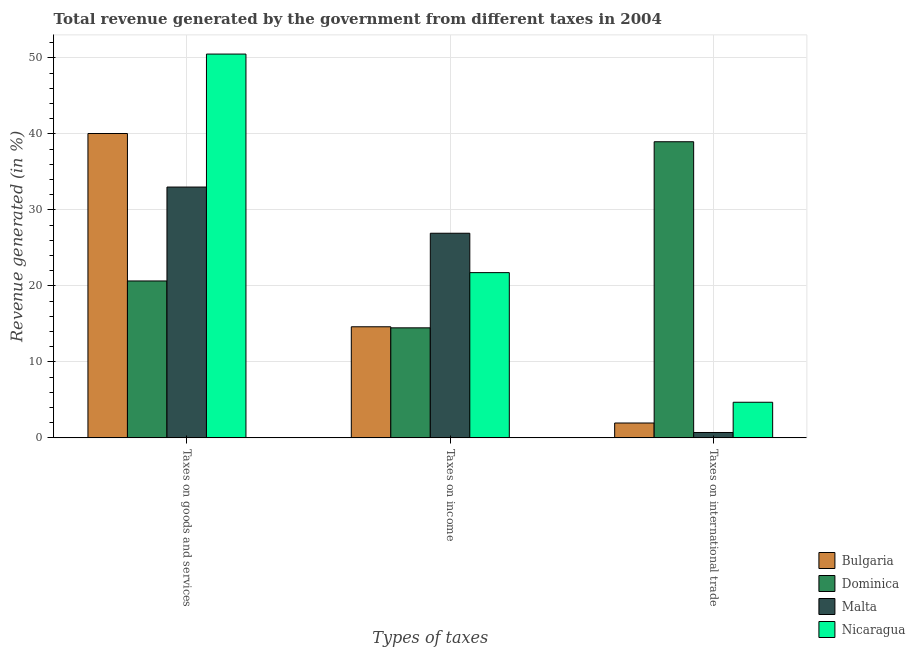Are the number of bars on each tick of the X-axis equal?
Ensure brevity in your answer.  Yes. How many bars are there on the 1st tick from the left?
Your answer should be compact. 4. How many bars are there on the 2nd tick from the right?
Your response must be concise. 4. What is the label of the 2nd group of bars from the left?
Offer a terse response. Taxes on income. What is the percentage of revenue generated by taxes on income in Bulgaria?
Make the answer very short. 14.62. Across all countries, what is the maximum percentage of revenue generated by taxes on goods and services?
Offer a terse response. 50.51. Across all countries, what is the minimum percentage of revenue generated by taxes on income?
Offer a terse response. 14.48. In which country was the percentage of revenue generated by taxes on goods and services maximum?
Your answer should be very brief. Nicaragua. In which country was the percentage of revenue generated by taxes on income minimum?
Your response must be concise. Dominica. What is the total percentage of revenue generated by taxes on goods and services in the graph?
Make the answer very short. 144.23. What is the difference between the percentage of revenue generated by taxes on goods and services in Nicaragua and that in Bulgaria?
Your response must be concise. 10.46. What is the difference between the percentage of revenue generated by taxes on goods and services in Bulgaria and the percentage of revenue generated by tax on international trade in Malta?
Provide a succinct answer. 39.35. What is the average percentage of revenue generated by taxes on goods and services per country?
Give a very brief answer. 36.06. What is the difference between the percentage of revenue generated by taxes on goods and services and percentage of revenue generated by tax on international trade in Bulgaria?
Your response must be concise. 38.1. What is the ratio of the percentage of revenue generated by taxes on income in Nicaragua to that in Dominica?
Give a very brief answer. 1.5. Is the percentage of revenue generated by tax on international trade in Dominica less than that in Malta?
Your response must be concise. No. Is the difference between the percentage of revenue generated by tax on international trade in Bulgaria and Malta greater than the difference between the percentage of revenue generated by taxes on goods and services in Bulgaria and Malta?
Ensure brevity in your answer.  No. What is the difference between the highest and the second highest percentage of revenue generated by tax on international trade?
Your response must be concise. 34.29. What is the difference between the highest and the lowest percentage of revenue generated by tax on international trade?
Your response must be concise. 38.26. Is the sum of the percentage of revenue generated by taxes on income in Nicaragua and Malta greater than the maximum percentage of revenue generated by taxes on goods and services across all countries?
Make the answer very short. No. What does the 3rd bar from the left in Taxes on income represents?
Ensure brevity in your answer.  Malta. What does the 3rd bar from the right in Taxes on goods and services represents?
Your answer should be compact. Dominica. How many bars are there?
Your answer should be compact. 12. Are all the bars in the graph horizontal?
Provide a short and direct response. No. Are the values on the major ticks of Y-axis written in scientific E-notation?
Give a very brief answer. No. Where does the legend appear in the graph?
Offer a terse response. Bottom right. How many legend labels are there?
Ensure brevity in your answer.  4. What is the title of the graph?
Provide a short and direct response. Total revenue generated by the government from different taxes in 2004. Does "Other small states" appear as one of the legend labels in the graph?
Make the answer very short. No. What is the label or title of the X-axis?
Ensure brevity in your answer.  Types of taxes. What is the label or title of the Y-axis?
Keep it short and to the point. Revenue generated (in %). What is the Revenue generated (in %) of Bulgaria in Taxes on goods and services?
Offer a terse response. 40.06. What is the Revenue generated (in %) of Dominica in Taxes on goods and services?
Your answer should be very brief. 20.65. What is the Revenue generated (in %) in Malta in Taxes on goods and services?
Provide a short and direct response. 33.01. What is the Revenue generated (in %) of Nicaragua in Taxes on goods and services?
Give a very brief answer. 50.51. What is the Revenue generated (in %) in Bulgaria in Taxes on income?
Keep it short and to the point. 14.62. What is the Revenue generated (in %) in Dominica in Taxes on income?
Provide a short and direct response. 14.48. What is the Revenue generated (in %) in Malta in Taxes on income?
Keep it short and to the point. 26.93. What is the Revenue generated (in %) of Nicaragua in Taxes on income?
Make the answer very short. 21.75. What is the Revenue generated (in %) of Bulgaria in Taxes on international trade?
Provide a succinct answer. 1.96. What is the Revenue generated (in %) in Dominica in Taxes on international trade?
Provide a succinct answer. 38.97. What is the Revenue generated (in %) of Malta in Taxes on international trade?
Provide a succinct answer. 0.71. What is the Revenue generated (in %) of Nicaragua in Taxes on international trade?
Give a very brief answer. 4.69. Across all Types of taxes, what is the maximum Revenue generated (in %) in Bulgaria?
Make the answer very short. 40.06. Across all Types of taxes, what is the maximum Revenue generated (in %) of Dominica?
Ensure brevity in your answer.  38.97. Across all Types of taxes, what is the maximum Revenue generated (in %) of Malta?
Your answer should be compact. 33.01. Across all Types of taxes, what is the maximum Revenue generated (in %) in Nicaragua?
Make the answer very short. 50.51. Across all Types of taxes, what is the minimum Revenue generated (in %) of Bulgaria?
Your response must be concise. 1.96. Across all Types of taxes, what is the minimum Revenue generated (in %) of Dominica?
Your response must be concise. 14.48. Across all Types of taxes, what is the minimum Revenue generated (in %) of Malta?
Give a very brief answer. 0.71. Across all Types of taxes, what is the minimum Revenue generated (in %) of Nicaragua?
Provide a succinct answer. 4.69. What is the total Revenue generated (in %) in Bulgaria in the graph?
Offer a terse response. 56.63. What is the total Revenue generated (in %) in Dominica in the graph?
Offer a very short reply. 74.1. What is the total Revenue generated (in %) of Malta in the graph?
Keep it short and to the point. 60.65. What is the total Revenue generated (in %) of Nicaragua in the graph?
Keep it short and to the point. 76.94. What is the difference between the Revenue generated (in %) of Bulgaria in Taxes on goods and services and that in Taxes on income?
Your answer should be very brief. 25.43. What is the difference between the Revenue generated (in %) of Dominica in Taxes on goods and services and that in Taxes on income?
Your response must be concise. 6.17. What is the difference between the Revenue generated (in %) of Malta in Taxes on goods and services and that in Taxes on income?
Provide a short and direct response. 6.08. What is the difference between the Revenue generated (in %) in Nicaragua in Taxes on goods and services and that in Taxes on income?
Offer a very short reply. 28.76. What is the difference between the Revenue generated (in %) in Bulgaria in Taxes on goods and services and that in Taxes on international trade?
Your answer should be compact. 38.1. What is the difference between the Revenue generated (in %) in Dominica in Taxes on goods and services and that in Taxes on international trade?
Provide a short and direct response. -18.32. What is the difference between the Revenue generated (in %) of Malta in Taxes on goods and services and that in Taxes on international trade?
Ensure brevity in your answer.  32.3. What is the difference between the Revenue generated (in %) in Nicaragua in Taxes on goods and services and that in Taxes on international trade?
Your response must be concise. 45.82. What is the difference between the Revenue generated (in %) in Bulgaria in Taxes on income and that in Taxes on international trade?
Keep it short and to the point. 12.66. What is the difference between the Revenue generated (in %) of Dominica in Taxes on income and that in Taxes on international trade?
Provide a short and direct response. -24.49. What is the difference between the Revenue generated (in %) of Malta in Taxes on income and that in Taxes on international trade?
Provide a short and direct response. 26.22. What is the difference between the Revenue generated (in %) in Nicaragua in Taxes on income and that in Taxes on international trade?
Offer a very short reply. 17.06. What is the difference between the Revenue generated (in %) in Bulgaria in Taxes on goods and services and the Revenue generated (in %) in Dominica in Taxes on income?
Offer a terse response. 25.57. What is the difference between the Revenue generated (in %) of Bulgaria in Taxes on goods and services and the Revenue generated (in %) of Malta in Taxes on income?
Provide a short and direct response. 13.13. What is the difference between the Revenue generated (in %) in Bulgaria in Taxes on goods and services and the Revenue generated (in %) in Nicaragua in Taxes on income?
Offer a terse response. 18.31. What is the difference between the Revenue generated (in %) of Dominica in Taxes on goods and services and the Revenue generated (in %) of Malta in Taxes on income?
Offer a very short reply. -6.28. What is the difference between the Revenue generated (in %) of Dominica in Taxes on goods and services and the Revenue generated (in %) of Nicaragua in Taxes on income?
Provide a succinct answer. -1.1. What is the difference between the Revenue generated (in %) of Malta in Taxes on goods and services and the Revenue generated (in %) of Nicaragua in Taxes on income?
Give a very brief answer. 11.26. What is the difference between the Revenue generated (in %) in Bulgaria in Taxes on goods and services and the Revenue generated (in %) in Dominica in Taxes on international trade?
Ensure brevity in your answer.  1.08. What is the difference between the Revenue generated (in %) of Bulgaria in Taxes on goods and services and the Revenue generated (in %) of Malta in Taxes on international trade?
Give a very brief answer. 39.35. What is the difference between the Revenue generated (in %) of Bulgaria in Taxes on goods and services and the Revenue generated (in %) of Nicaragua in Taxes on international trade?
Make the answer very short. 35.37. What is the difference between the Revenue generated (in %) in Dominica in Taxes on goods and services and the Revenue generated (in %) in Malta in Taxes on international trade?
Offer a terse response. 19.94. What is the difference between the Revenue generated (in %) in Dominica in Taxes on goods and services and the Revenue generated (in %) in Nicaragua in Taxes on international trade?
Your response must be concise. 15.96. What is the difference between the Revenue generated (in %) in Malta in Taxes on goods and services and the Revenue generated (in %) in Nicaragua in Taxes on international trade?
Keep it short and to the point. 28.32. What is the difference between the Revenue generated (in %) of Bulgaria in Taxes on income and the Revenue generated (in %) of Dominica in Taxes on international trade?
Provide a succinct answer. -24.35. What is the difference between the Revenue generated (in %) of Bulgaria in Taxes on income and the Revenue generated (in %) of Malta in Taxes on international trade?
Your answer should be compact. 13.91. What is the difference between the Revenue generated (in %) of Bulgaria in Taxes on income and the Revenue generated (in %) of Nicaragua in Taxes on international trade?
Make the answer very short. 9.93. What is the difference between the Revenue generated (in %) in Dominica in Taxes on income and the Revenue generated (in %) in Malta in Taxes on international trade?
Offer a very short reply. 13.77. What is the difference between the Revenue generated (in %) in Dominica in Taxes on income and the Revenue generated (in %) in Nicaragua in Taxes on international trade?
Your answer should be very brief. 9.79. What is the difference between the Revenue generated (in %) in Malta in Taxes on income and the Revenue generated (in %) in Nicaragua in Taxes on international trade?
Your answer should be very brief. 22.24. What is the average Revenue generated (in %) of Bulgaria per Types of taxes?
Your response must be concise. 18.88. What is the average Revenue generated (in %) of Dominica per Types of taxes?
Provide a succinct answer. 24.7. What is the average Revenue generated (in %) of Malta per Types of taxes?
Give a very brief answer. 20.22. What is the average Revenue generated (in %) in Nicaragua per Types of taxes?
Your answer should be very brief. 25.65. What is the difference between the Revenue generated (in %) in Bulgaria and Revenue generated (in %) in Dominica in Taxes on goods and services?
Your response must be concise. 19.41. What is the difference between the Revenue generated (in %) of Bulgaria and Revenue generated (in %) of Malta in Taxes on goods and services?
Your response must be concise. 7.05. What is the difference between the Revenue generated (in %) of Bulgaria and Revenue generated (in %) of Nicaragua in Taxes on goods and services?
Offer a terse response. -10.46. What is the difference between the Revenue generated (in %) in Dominica and Revenue generated (in %) in Malta in Taxes on goods and services?
Make the answer very short. -12.36. What is the difference between the Revenue generated (in %) in Dominica and Revenue generated (in %) in Nicaragua in Taxes on goods and services?
Your answer should be compact. -29.86. What is the difference between the Revenue generated (in %) in Malta and Revenue generated (in %) in Nicaragua in Taxes on goods and services?
Make the answer very short. -17.5. What is the difference between the Revenue generated (in %) of Bulgaria and Revenue generated (in %) of Dominica in Taxes on income?
Your answer should be very brief. 0.14. What is the difference between the Revenue generated (in %) of Bulgaria and Revenue generated (in %) of Malta in Taxes on income?
Provide a succinct answer. -12.31. What is the difference between the Revenue generated (in %) of Bulgaria and Revenue generated (in %) of Nicaragua in Taxes on income?
Your response must be concise. -7.13. What is the difference between the Revenue generated (in %) of Dominica and Revenue generated (in %) of Malta in Taxes on income?
Keep it short and to the point. -12.45. What is the difference between the Revenue generated (in %) of Dominica and Revenue generated (in %) of Nicaragua in Taxes on income?
Your answer should be very brief. -7.27. What is the difference between the Revenue generated (in %) of Malta and Revenue generated (in %) of Nicaragua in Taxes on income?
Provide a succinct answer. 5.18. What is the difference between the Revenue generated (in %) of Bulgaria and Revenue generated (in %) of Dominica in Taxes on international trade?
Offer a very short reply. -37.02. What is the difference between the Revenue generated (in %) in Bulgaria and Revenue generated (in %) in Malta in Taxes on international trade?
Your answer should be compact. 1.25. What is the difference between the Revenue generated (in %) in Bulgaria and Revenue generated (in %) in Nicaragua in Taxes on international trade?
Give a very brief answer. -2.73. What is the difference between the Revenue generated (in %) of Dominica and Revenue generated (in %) of Malta in Taxes on international trade?
Your response must be concise. 38.26. What is the difference between the Revenue generated (in %) of Dominica and Revenue generated (in %) of Nicaragua in Taxes on international trade?
Your answer should be compact. 34.29. What is the difference between the Revenue generated (in %) in Malta and Revenue generated (in %) in Nicaragua in Taxes on international trade?
Give a very brief answer. -3.98. What is the ratio of the Revenue generated (in %) of Bulgaria in Taxes on goods and services to that in Taxes on income?
Your response must be concise. 2.74. What is the ratio of the Revenue generated (in %) of Dominica in Taxes on goods and services to that in Taxes on income?
Your answer should be very brief. 1.43. What is the ratio of the Revenue generated (in %) of Malta in Taxes on goods and services to that in Taxes on income?
Your answer should be compact. 1.23. What is the ratio of the Revenue generated (in %) of Nicaragua in Taxes on goods and services to that in Taxes on income?
Give a very brief answer. 2.32. What is the ratio of the Revenue generated (in %) of Bulgaria in Taxes on goods and services to that in Taxes on international trade?
Provide a succinct answer. 20.47. What is the ratio of the Revenue generated (in %) in Dominica in Taxes on goods and services to that in Taxes on international trade?
Keep it short and to the point. 0.53. What is the ratio of the Revenue generated (in %) in Malta in Taxes on goods and services to that in Taxes on international trade?
Give a very brief answer. 46.61. What is the ratio of the Revenue generated (in %) in Nicaragua in Taxes on goods and services to that in Taxes on international trade?
Your answer should be very brief. 10.78. What is the ratio of the Revenue generated (in %) of Bulgaria in Taxes on income to that in Taxes on international trade?
Give a very brief answer. 7.47. What is the ratio of the Revenue generated (in %) in Dominica in Taxes on income to that in Taxes on international trade?
Your answer should be very brief. 0.37. What is the ratio of the Revenue generated (in %) of Malta in Taxes on income to that in Taxes on international trade?
Provide a short and direct response. 38.03. What is the ratio of the Revenue generated (in %) of Nicaragua in Taxes on income to that in Taxes on international trade?
Provide a succinct answer. 4.64. What is the difference between the highest and the second highest Revenue generated (in %) of Bulgaria?
Make the answer very short. 25.43. What is the difference between the highest and the second highest Revenue generated (in %) in Dominica?
Provide a short and direct response. 18.32. What is the difference between the highest and the second highest Revenue generated (in %) of Malta?
Give a very brief answer. 6.08. What is the difference between the highest and the second highest Revenue generated (in %) of Nicaragua?
Provide a succinct answer. 28.76. What is the difference between the highest and the lowest Revenue generated (in %) in Bulgaria?
Give a very brief answer. 38.1. What is the difference between the highest and the lowest Revenue generated (in %) in Dominica?
Offer a terse response. 24.49. What is the difference between the highest and the lowest Revenue generated (in %) in Malta?
Provide a short and direct response. 32.3. What is the difference between the highest and the lowest Revenue generated (in %) in Nicaragua?
Offer a very short reply. 45.82. 